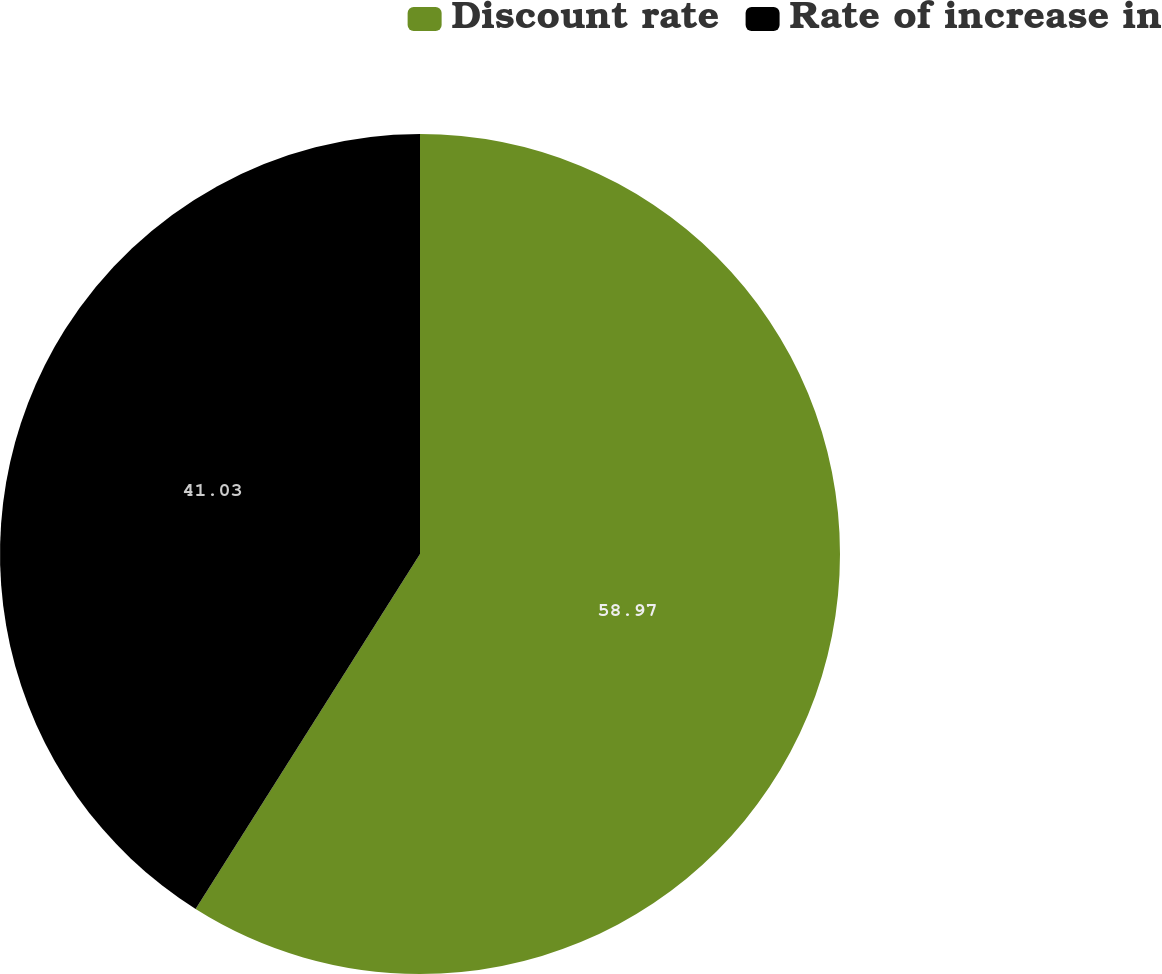Convert chart to OTSL. <chart><loc_0><loc_0><loc_500><loc_500><pie_chart><fcel>Discount rate<fcel>Rate of increase in<nl><fcel>58.97%<fcel>41.03%<nl></chart> 